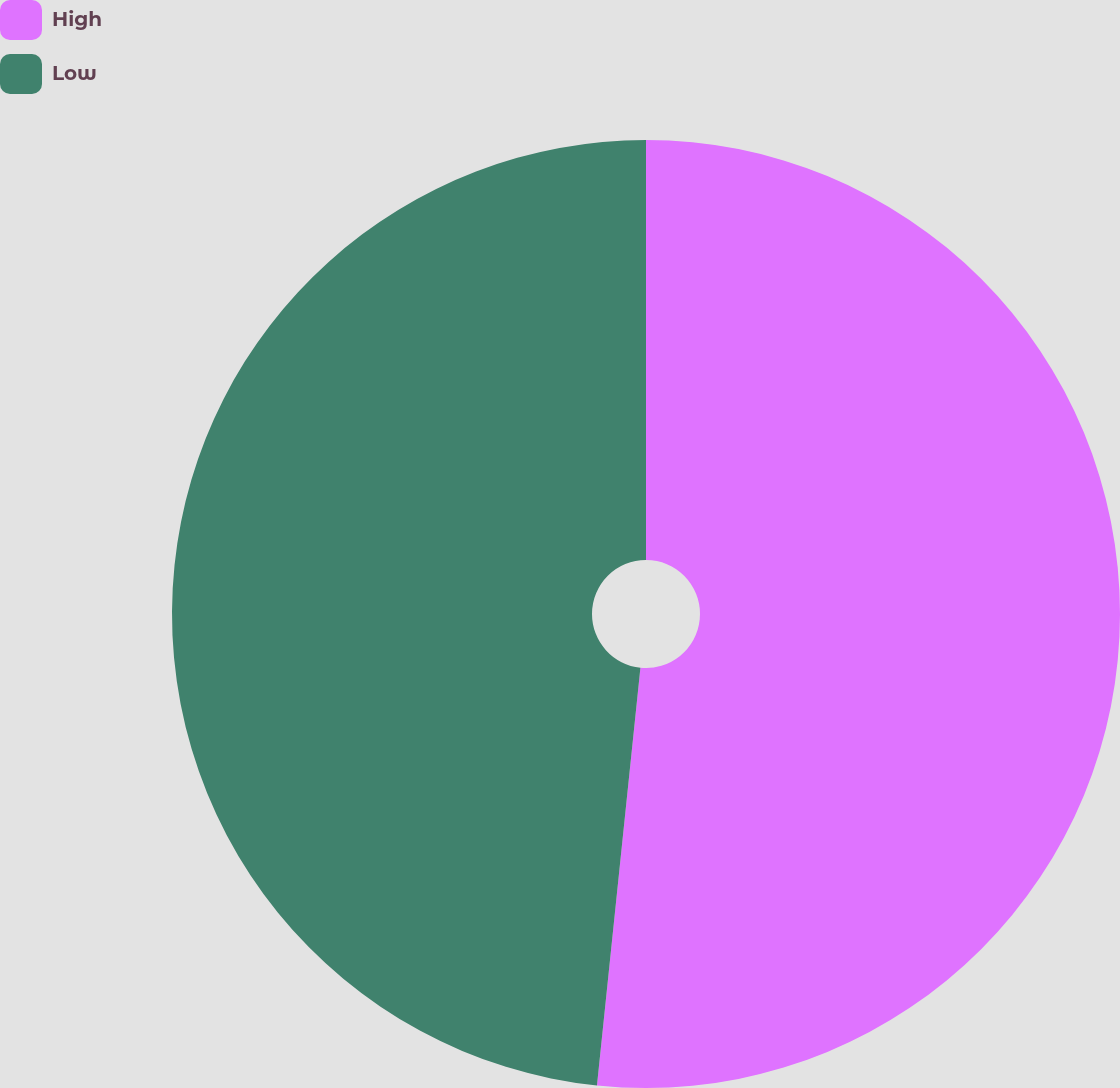Convert chart. <chart><loc_0><loc_0><loc_500><loc_500><pie_chart><fcel>High<fcel>Low<nl><fcel>51.65%<fcel>48.35%<nl></chart> 